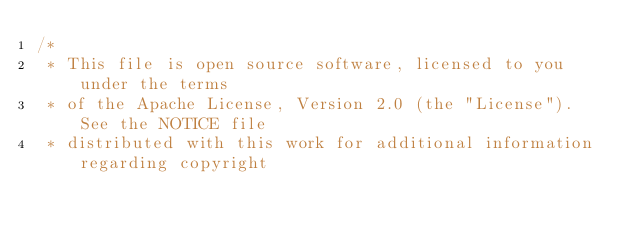Convert code to text. <code><loc_0><loc_0><loc_500><loc_500><_C++_>/*
 * This file is open source software, licensed to you under the terms
 * of the Apache License, Version 2.0 (the "License").  See the NOTICE file
 * distributed with this work for additional information regarding copyright</code> 